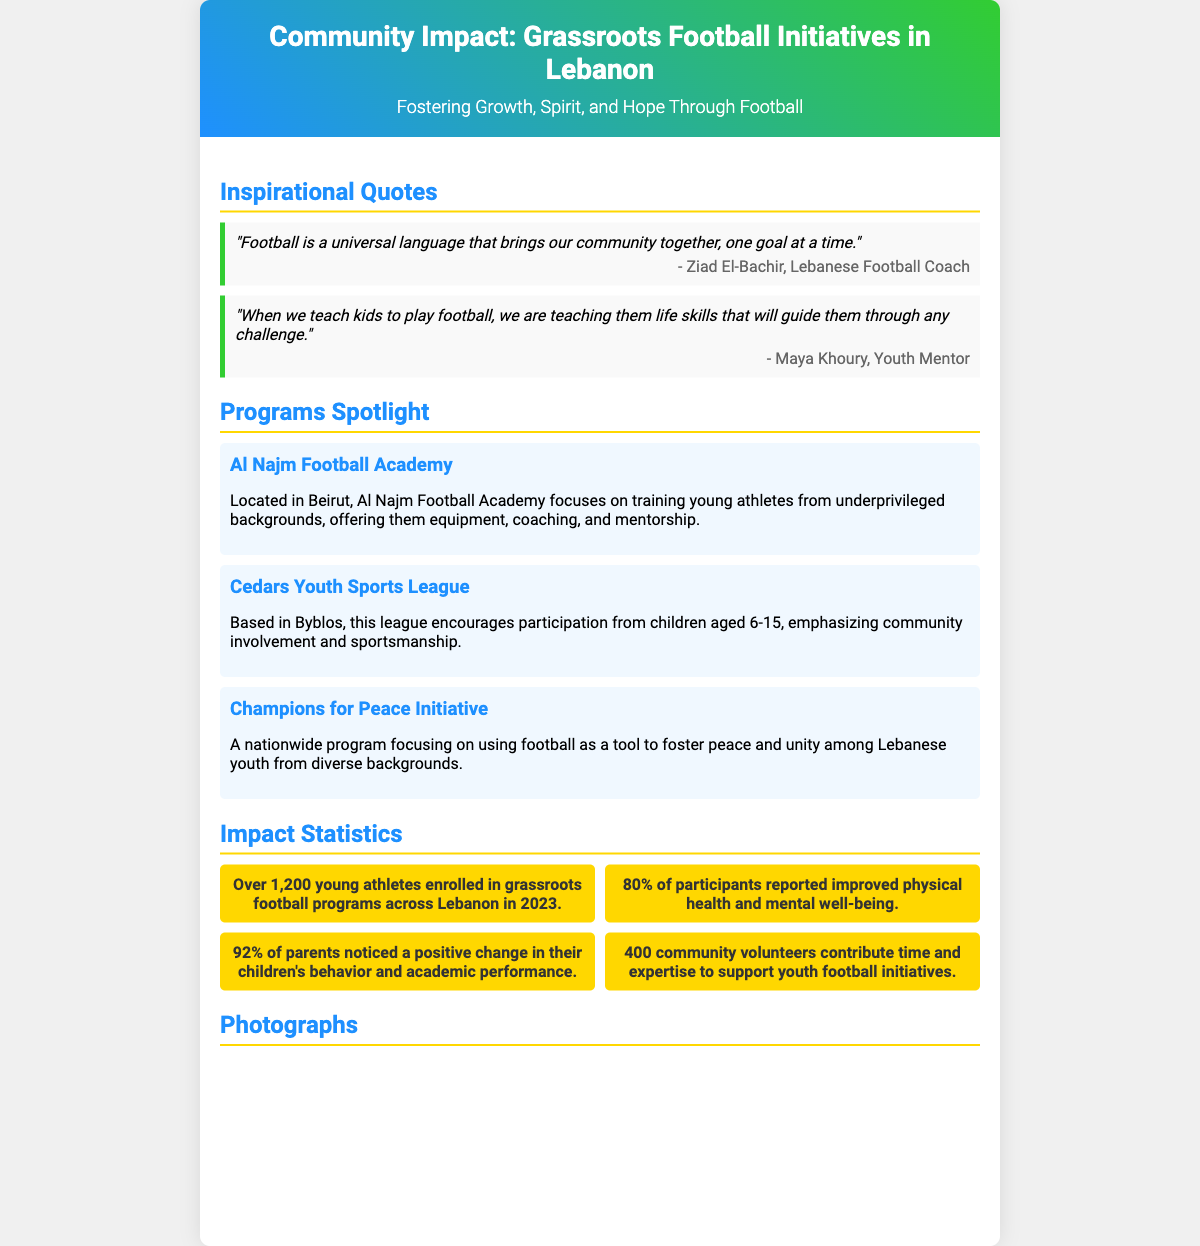What is the title of the poster? The title of the poster is prominently displayed at the top and reads "Community Impact: Grassroots Football Initiatives in Lebanon."
Answer: Community Impact: Grassroots Football Initiatives in Lebanon How many young athletes are enrolled in grassroots football programs? The document states that over 1,200 young athletes are enrolled in grassroots football programs across Lebanon in 2023.
Answer: Over 1,200 Who is the coach quoted in the poster? The poster features a quote from Ziad El-Bachir, who is identified as a Lebanese Football Coach.
Answer: Ziad El-Bachir What is the primary focus of the Al Najm Football Academy? The primary focus of Al Najm Football Academy, as mentioned in the document, is training young athletes from underprivileged backgrounds.
Answer: Training young athletes from underprivileged backgrounds What percentage of participants reported improved health and well-being? The poster notes that 80% of participants reported improved physical health and mental well-being.
Answer: 80% Which community program emphasizes peace and unity? The program that focuses on using football as a tool to foster peace and unity is identified as the Champions for Peace Initiative.
Answer: Champions for Peace Initiative How many community volunteers support youth football initiatives? The document states that 400 community volunteers contribute time and expertise to support youth football initiatives.
Answer: 400 What color is used for the header background on the poster? The header background features a gradient that includes shades of blue and green, specifically #1E90FF and #32CD32.
Answer: Blue and green 